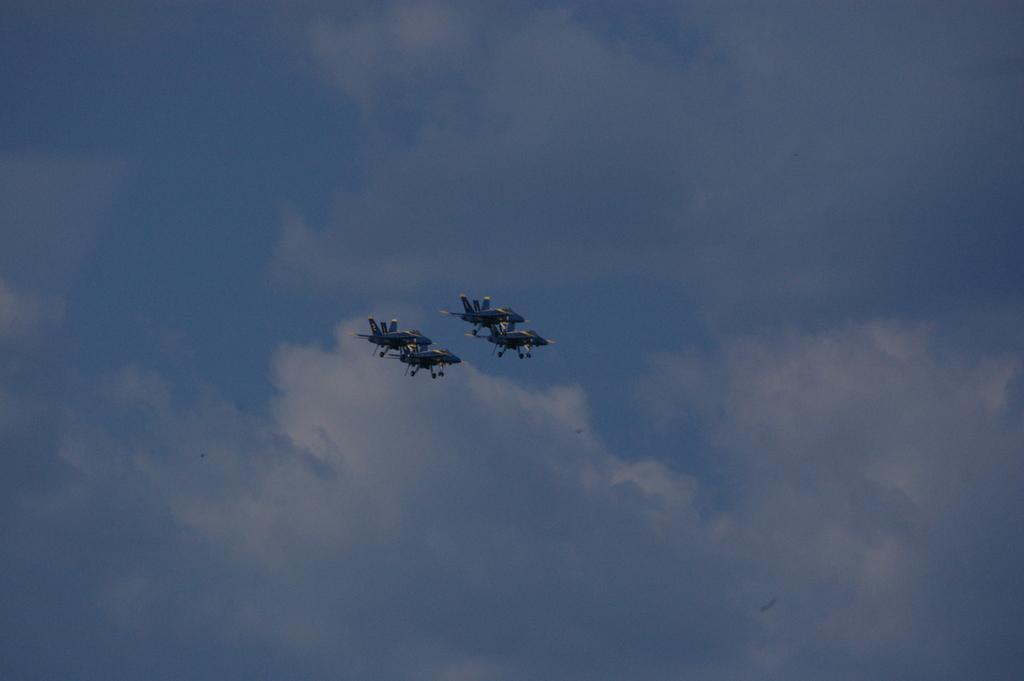Describe this image in one or two sentences. Here in this picture we can see fighter aircrafts flying in the air and we can see clouds in the sky. 